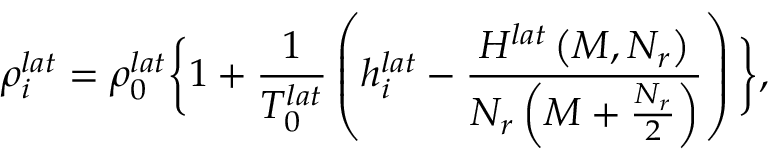<formula> <loc_0><loc_0><loc_500><loc_500>\rho _ { i } ^ { l a t } = \rho _ { 0 } ^ { l a t } \left \{ 1 + \frac { 1 } { T _ { 0 } ^ { l a t } } \left ( h _ { i } ^ { l a t } - \frac { H ^ { l a t } \left ( M , N _ { r } \right ) } { N _ { r } \left ( M + \frac { N _ { r } } { 2 } \right ) } \right ) \right \} ,</formula> 